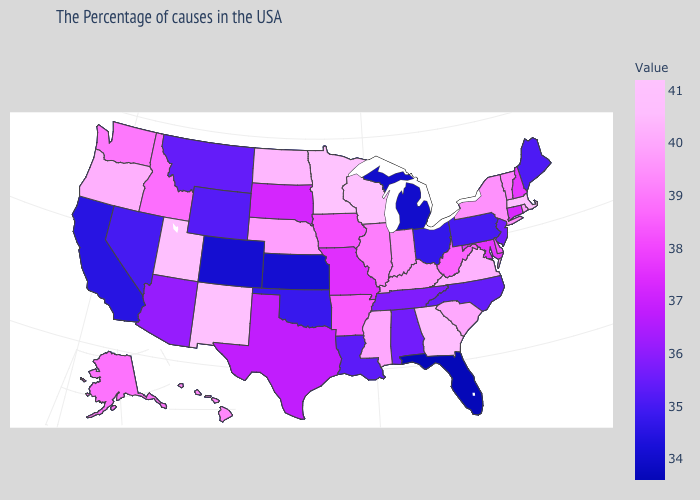Among the states that border Nebraska , which have the highest value?
Keep it brief. Iowa. Which states have the highest value in the USA?
Be succinct. Minnesota. Does Oklahoma have a lower value than Rhode Island?
Write a very short answer. Yes. Does Pennsylvania have a lower value than Florida?
Concise answer only. No. Does Maryland have a higher value than Arizona?
Short answer required. Yes. Which states have the highest value in the USA?
Quick response, please. Minnesota. Does the map have missing data?
Short answer required. No. 